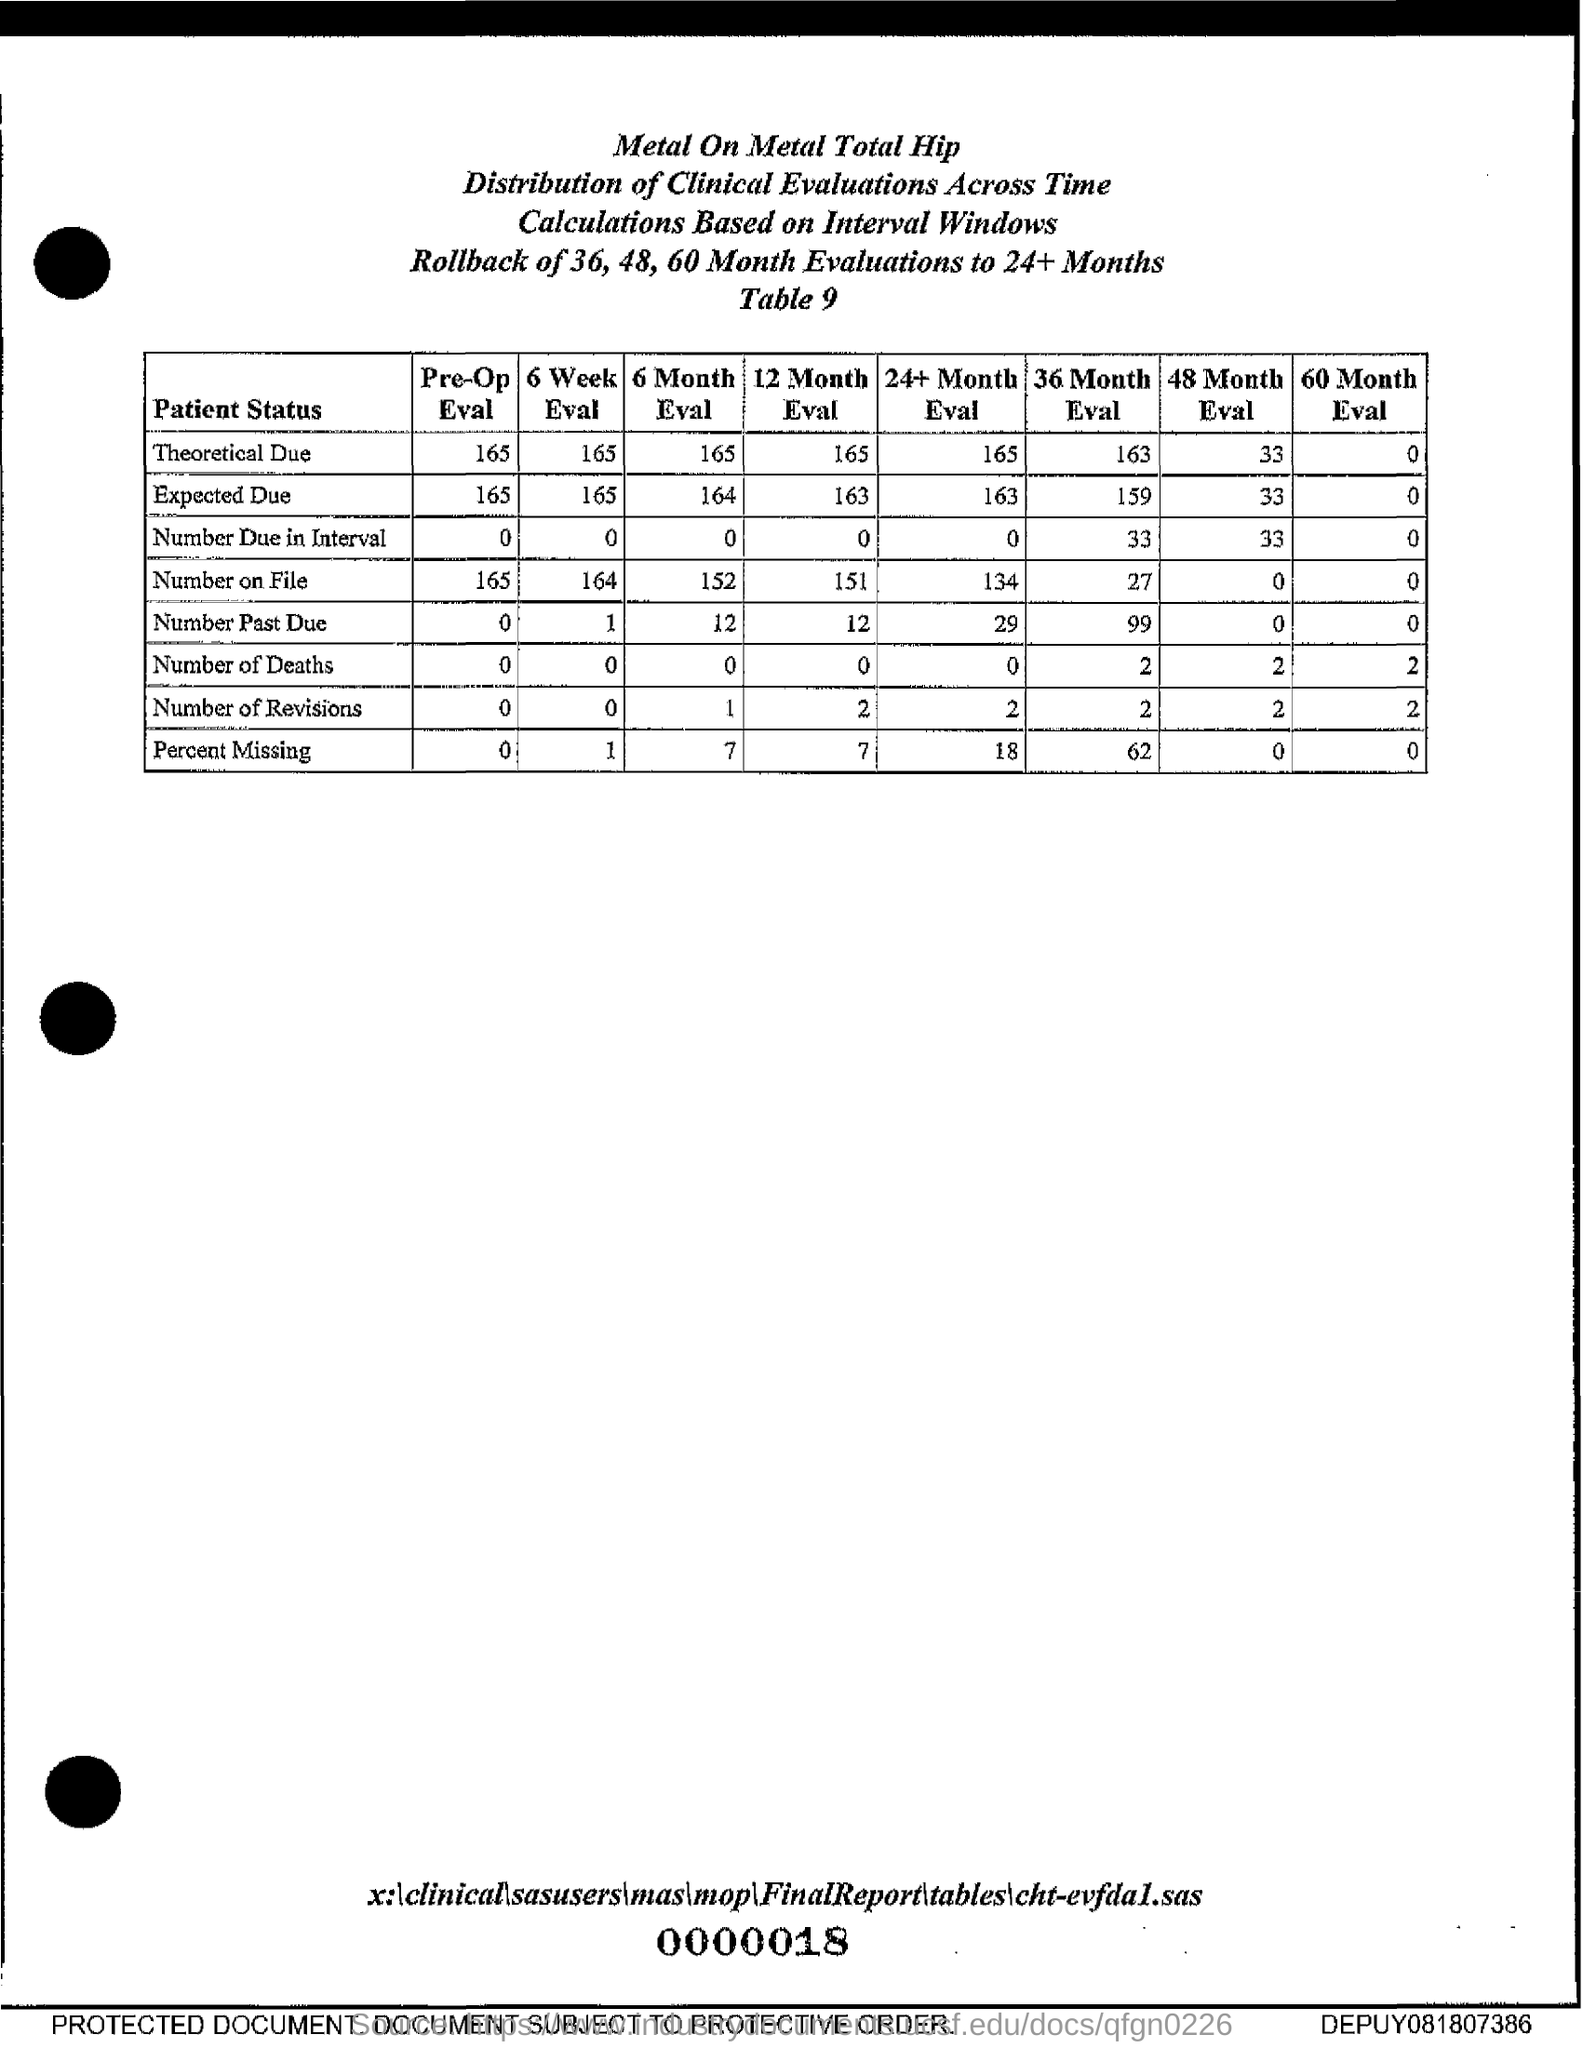Draw attention to some important aspects in this diagram. The pre-op evaluation for the number on file is 165. The 6-month evaluation for the number on file is 152. The 6 Month Evaluation for the Number of Revisions will be conducted over a period of 1 to 1. The Pre-Op Evaluation for patients with a due-in interval of 0 to 0 is a crucial step in the surgical process, ensuring that all necessary precautions are taken to ensure the safety and well-being of both the patient and the surgeon. The pre-op evaluation for expected due date of 165 is a necessary step in preparation for the delivery of a child. 